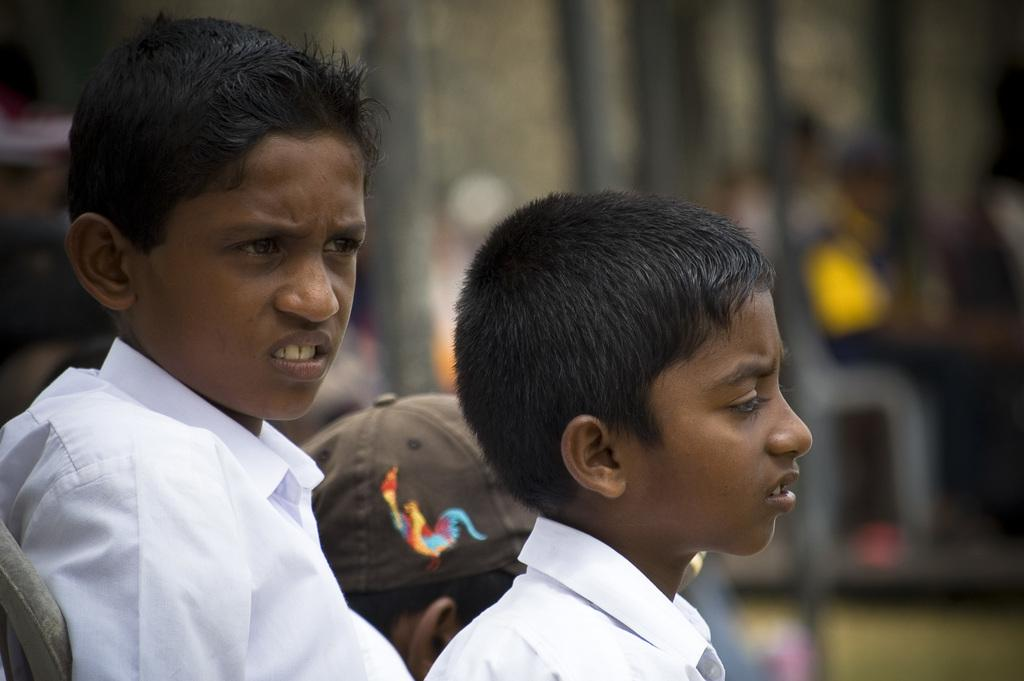How many boys are in the image? There are two boys in the foreground of the image. What is the person in the middle of the boys wearing? The person is wearing a cap. Can you describe the background of the image? The background of the image is blurry. How much money is the mom holding in the image? There is no mom or money present in the image. How many balls are visible in the image? There are no balls visible in the image. 